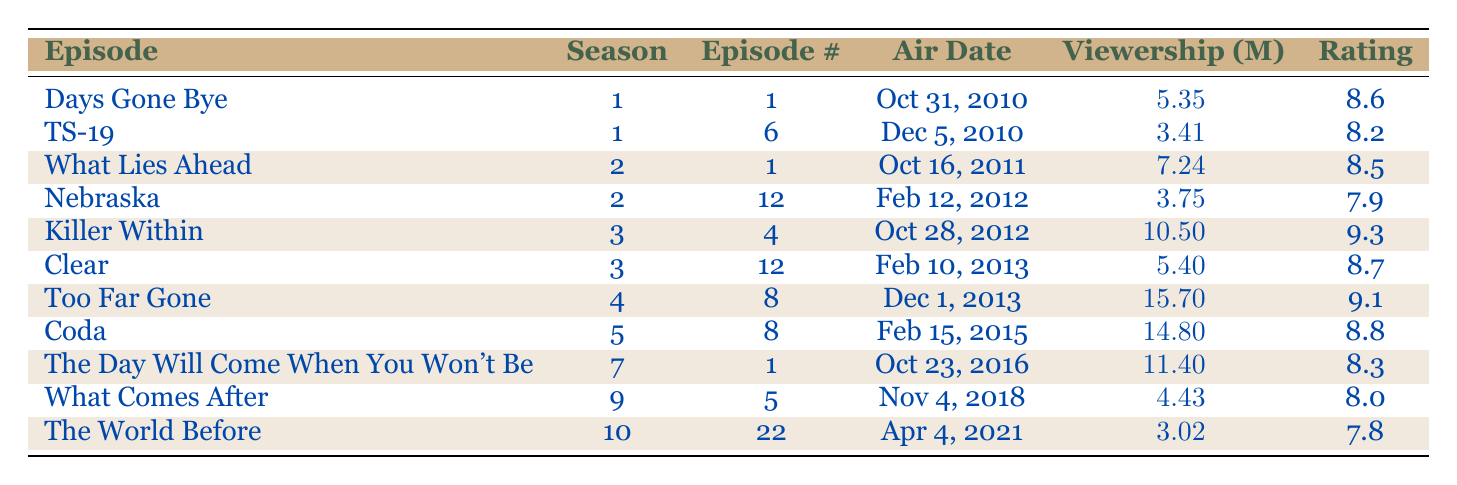What is the episode title with the highest viewership? By examining the viewership column for each episode, I see that "Too Far Gone" has the highest value at 15.7 million viewers, which is greater than the other episodes listed.
Answer: Too Far Gone Which episode has the lowest rating? I check the rating column for each episode and note that "Nebraska" has the lowest rating of 7.9, compared to the others which are all higher.
Answer: Nebraska What is the average viewership of episodes in Season 3? The episodes in Season 3 are "Killer Within" (10.5), "Clear" (5.4), and the total is 10.5 + 5.4 = 15.9. There are 2 episodes, so averaging gives 15.9 / 2 = 7.95 million viewers.
Answer: 7.95 Was "Days Gone Bye" more popular than "What Comes After"? I compare the viewership of both episodes: "Days Gone Bye" has 5.35 million viewers, while "What Comes After" has 4.43 million viewers. Since 5.35 is greater than 4.43, "Days Gone Bye" was more popular.
Answer: Yes How many episodes have a rating above 8.5? I go through the rating column and count the episodes: "Killer Within" (9.3), "Too Far Gone" (9.1), "Coda" (8.8), and "Clear" (8.7) all have ratings above 8.5. That totals 4 episodes.
Answer: 4 What is the difference in viewership between the most and least viewed episodes? The most viewed episode is "Too Far Gone" with 15.7 million viewers, and the least viewed is "The World Before" with 3.02 million viewers. I calculate the difference as 15.7 - 3.02 = 12.68 million viewers.
Answer: 12.68 How many episodes in total are there between Seasons 1 and 2? The episodes in Season 1 are "Days Gone Bye" and "TS-19" (2 episodes), and those in Season 2 are "What Lies Ahead" and "Nebraska" (2 episodes). The total for Seasons 1 and 2 is 2 + 2 = 4 episodes.
Answer: 4 Is the viewership of "Coda" higher than that of "The Day Will Come When You Won't Be"? I find that "Coda" has 14.8 million viewers and "The Day Will Come When You Won't Be" has 11.4 million viewers. Since 14.8 is greater than 11.4, "Coda" has higher viewership.
Answer: Yes Which season has the episode with the highest rating? The episode with the highest rating is "Killer Within," which is in Season 3 with a rating of 9.3. No other episode has a higher rating, so Season 3 has the highest-rated episode.
Answer: Season 3 